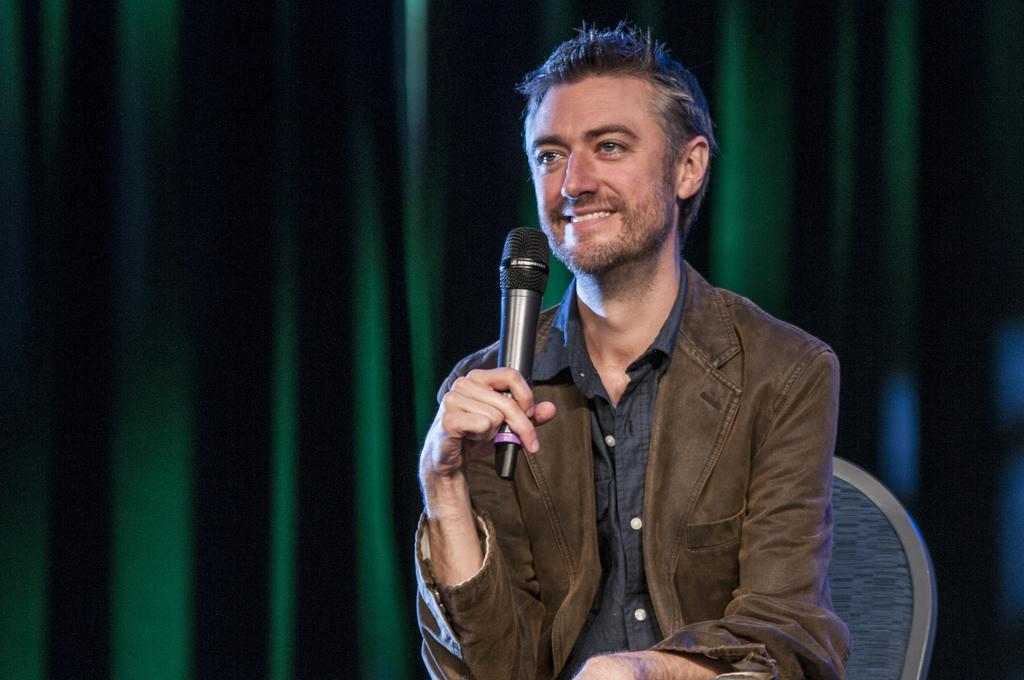What is the man in the image doing? The man is sitting in the chairs and holding a microphone in his hand. What is the man wearing in the image? The man is wearing a brown coat. What is the man's facial expression in the image? The man is smiling. What can be seen in the background of the image? There is a green color curtain in the background. What type of grape is the beggar holding in the image? There is no beggar or grape present in the image. Is there any blood visible on the man's coat in the image? There is no blood visible on the man's coat in the image. 